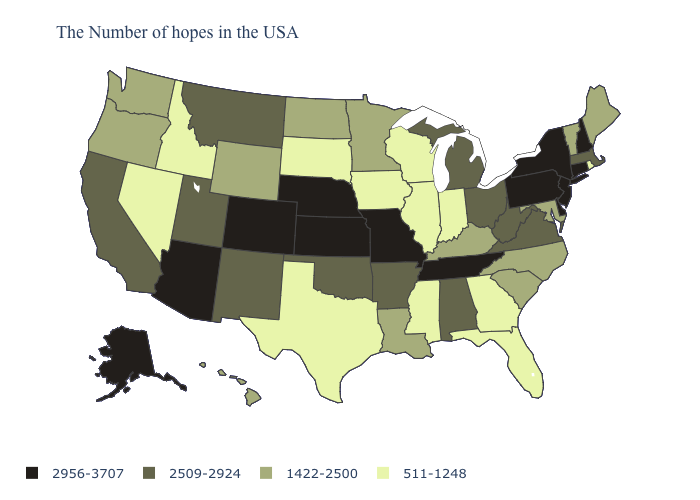Among the states that border North Dakota , does South Dakota have the highest value?
Keep it brief. No. What is the value of Kentucky?
Concise answer only. 1422-2500. Among the states that border Utah , which have the highest value?
Keep it brief. Colorado, Arizona. What is the value of Pennsylvania?
Quick response, please. 2956-3707. What is the value of Delaware?
Short answer required. 2956-3707. What is the value of Colorado?
Short answer required. 2956-3707. Which states have the lowest value in the USA?
Concise answer only. Rhode Island, Florida, Georgia, Indiana, Wisconsin, Illinois, Mississippi, Iowa, Texas, South Dakota, Idaho, Nevada. What is the value of Virginia?
Short answer required. 2509-2924. Name the states that have a value in the range 1422-2500?
Be succinct. Maine, Vermont, Maryland, North Carolina, South Carolina, Kentucky, Louisiana, Minnesota, North Dakota, Wyoming, Washington, Oregon, Hawaii. What is the value of Mississippi?
Short answer required. 511-1248. Among the states that border Illinois , which have the highest value?
Write a very short answer. Missouri. Is the legend a continuous bar?
Short answer required. No. What is the lowest value in the Northeast?
Be succinct. 511-1248. Does Rhode Island have a lower value than Virginia?
Quick response, please. Yes. Which states have the lowest value in the South?
Give a very brief answer. Florida, Georgia, Mississippi, Texas. 